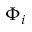Convert formula to latex. <formula><loc_0><loc_0><loc_500><loc_500>\Phi _ { i }</formula> 